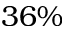Convert formula to latex. <formula><loc_0><loc_0><loc_500><loc_500>3 6 \%</formula> 